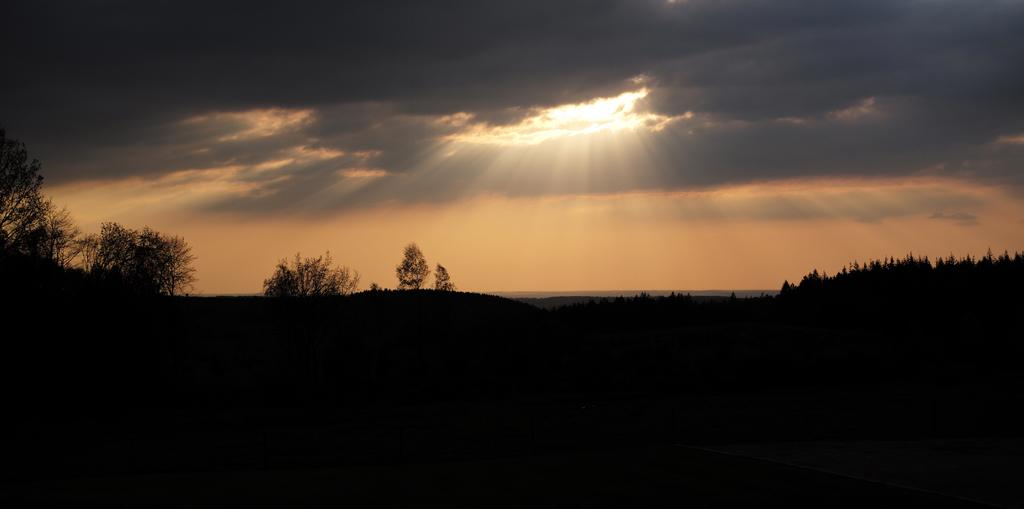What type of vegetation can be seen in the image? There are trees visible in the image. What can be seen in the sky in the image? There are clouds in the sky in the image. What type of beef is being cooked on the pipe in the image? There is no beef or pipe present in the image. What type of play is being performed by the actors in the image? There are no actors or play present in the image; it features trees and clouds. 